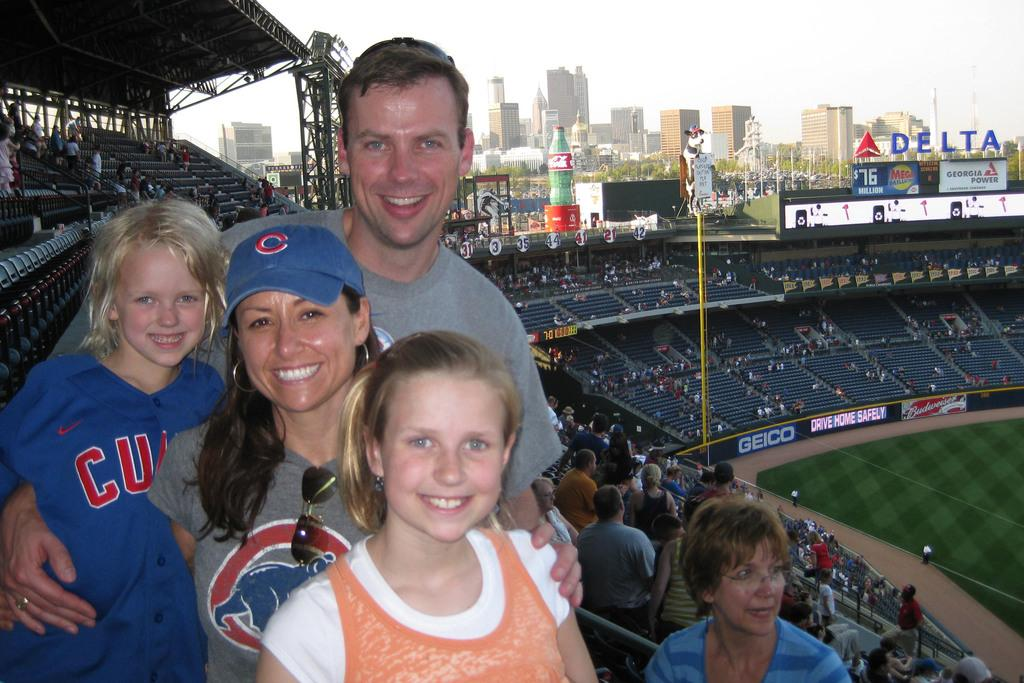<image>
Offer a succinct explanation of the picture presented. A woman with a C on her hat poses with her family. 